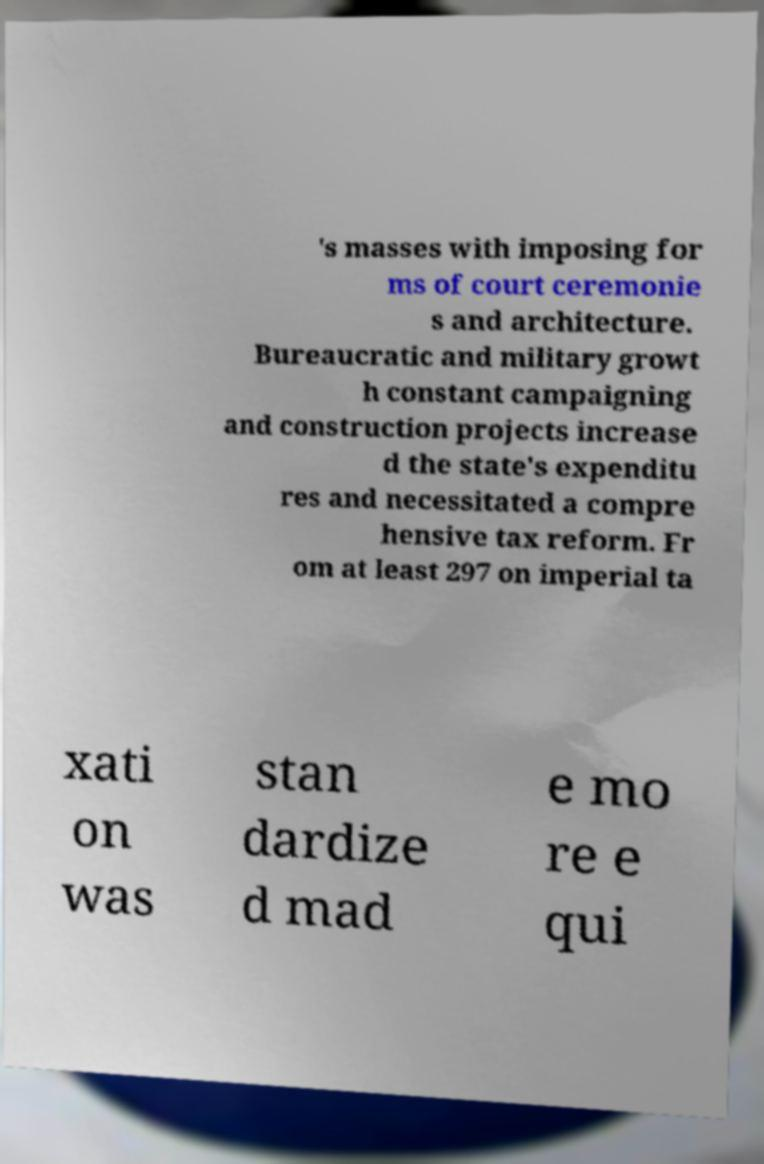What messages or text are displayed in this image? I need them in a readable, typed format. 's masses with imposing for ms of court ceremonie s and architecture. Bureaucratic and military growt h constant campaigning and construction projects increase d the state's expenditu res and necessitated a compre hensive tax reform. Fr om at least 297 on imperial ta xati on was stan dardize d mad e mo re e qui 